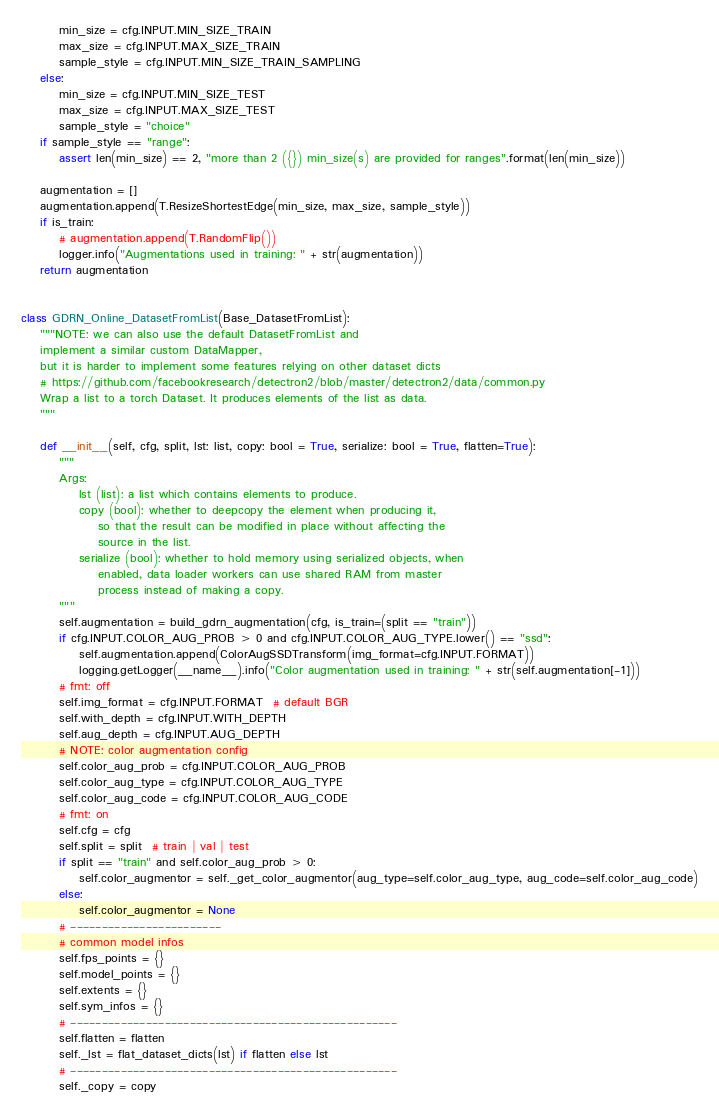<code> <loc_0><loc_0><loc_500><loc_500><_Python_>        min_size = cfg.INPUT.MIN_SIZE_TRAIN
        max_size = cfg.INPUT.MAX_SIZE_TRAIN
        sample_style = cfg.INPUT.MIN_SIZE_TRAIN_SAMPLING
    else:
        min_size = cfg.INPUT.MIN_SIZE_TEST
        max_size = cfg.INPUT.MAX_SIZE_TEST
        sample_style = "choice"
    if sample_style == "range":
        assert len(min_size) == 2, "more than 2 ({}) min_size(s) are provided for ranges".format(len(min_size))

    augmentation = []
    augmentation.append(T.ResizeShortestEdge(min_size, max_size, sample_style))
    if is_train:
        # augmentation.append(T.RandomFlip())
        logger.info("Augmentations used in training: " + str(augmentation))
    return augmentation


class GDRN_Online_DatasetFromList(Base_DatasetFromList):
    """NOTE: we can also use the default DatasetFromList and
    implement a similar custom DataMapper,
    but it is harder to implement some features relying on other dataset dicts
    # https://github.com/facebookresearch/detectron2/blob/master/detectron2/data/common.py
    Wrap a list to a torch Dataset. It produces elements of the list as data.
    """

    def __init__(self, cfg, split, lst: list, copy: bool = True, serialize: bool = True, flatten=True):
        """
        Args:
            lst (list): a list which contains elements to produce.
            copy (bool): whether to deepcopy the element when producing it,
                so that the result can be modified in place without affecting the
                source in the list.
            serialize (bool): whether to hold memory using serialized objects, when
                enabled, data loader workers can use shared RAM from master
                process instead of making a copy.
        """
        self.augmentation = build_gdrn_augmentation(cfg, is_train=(split == "train"))
        if cfg.INPUT.COLOR_AUG_PROB > 0 and cfg.INPUT.COLOR_AUG_TYPE.lower() == "ssd":
            self.augmentation.append(ColorAugSSDTransform(img_format=cfg.INPUT.FORMAT))
            logging.getLogger(__name__).info("Color augmentation used in training: " + str(self.augmentation[-1]))
        # fmt: off
        self.img_format = cfg.INPUT.FORMAT  # default BGR
        self.with_depth = cfg.INPUT.WITH_DEPTH
        self.aug_depth = cfg.INPUT.AUG_DEPTH
        # NOTE: color augmentation config
        self.color_aug_prob = cfg.INPUT.COLOR_AUG_PROB
        self.color_aug_type = cfg.INPUT.COLOR_AUG_TYPE
        self.color_aug_code = cfg.INPUT.COLOR_AUG_CODE
        # fmt: on
        self.cfg = cfg
        self.split = split  # train | val | test
        if split == "train" and self.color_aug_prob > 0:
            self.color_augmentor = self._get_color_augmentor(aug_type=self.color_aug_type, aug_code=self.color_aug_code)
        else:
            self.color_augmentor = None
        # ------------------------
        # common model infos
        self.fps_points = {}
        self.model_points = {}
        self.extents = {}
        self.sym_infos = {}
        # ----------------------------------------------------
        self.flatten = flatten
        self._lst = flat_dataset_dicts(lst) if flatten else lst
        # ----------------------------------------------------
        self._copy = copy</code> 